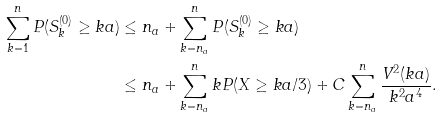Convert formula to latex. <formula><loc_0><loc_0><loc_500><loc_500>\sum _ { k = 1 } ^ { n } P ( S _ { k } ^ { ( 0 ) } \geq k a ) & \leq n _ { a } + \sum _ { k = n _ { a } } ^ { n } P ( S _ { k } ^ { ( 0 ) } \geq k a ) \\ & \leq n _ { a } + \sum _ { k = n _ { a } } ^ { n } k P ( X \geq k a / 3 ) + C \sum _ { k = n _ { a } } ^ { n } \frac { V ^ { 2 } ( k a ) } { k ^ { 2 } a ^ { 4 } } .</formula> 